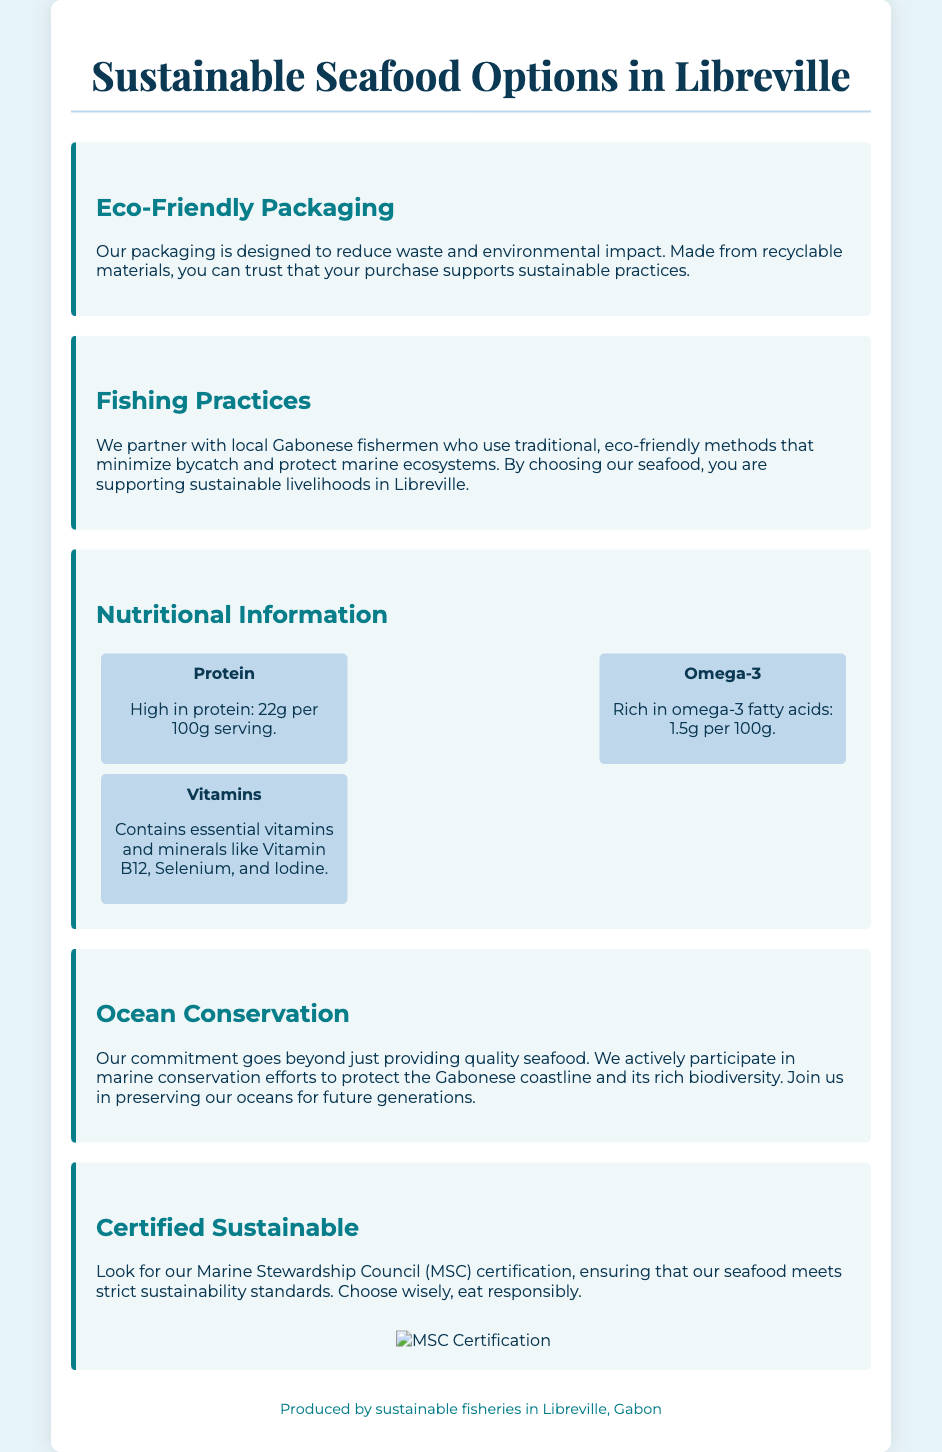What is the title of the document? The title of the document is found at the top of the content section.
Answer: Sustainable Seafood Options in Libreville What is the protein content per 100g serving? The document states the protein content within the Nutritional Information section.
Answer: 22g Which organization certifies the seafood? The certification body is mentioned in the Certified Sustainable section of the document.
Answer: Marine Stewardship Council (MSC) What fishing methods do local fishermen use? The document specifies the fishing methods used in the Fishing Practices section.
Answer: Traditional, eco-friendly methods What is the primary purpose of the ECO-Friendly Packaging? The section explains the goal of eco-friendly packaging in the document.
Answer: Reduce waste and environmental impact How much omega-3 is present per 100g? The omega-3 content is detailed in the Nutritional Information section.
Answer: 1.5g What commitment does the company have towards marine conservation? The document outlines the commitment in the Ocean Conservation section.
Answer: Actively participate in marine conservation efforts What type of materials is the packaging made from? The materials used for the packaging are specified in the Eco-Friendly Packaging section.
Answer: Recyclable materials 